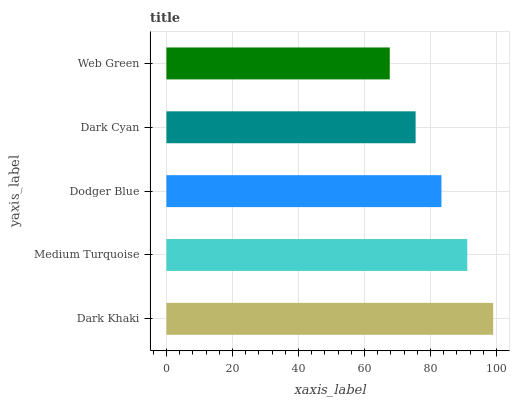Is Web Green the minimum?
Answer yes or no. Yes. Is Dark Khaki the maximum?
Answer yes or no. Yes. Is Medium Turquoise the minimum?
Answer yes or no. No. Is Medium Turquoise the maximum?
Answer yes or no. No. Is Dark Khaki greater than Medium Turquoise?
Answer yes or no. Yes. Is Medium Turquoise less than Dark Khaki?
Answer yes or no. Yes. Is Medium Turquoise greater than Dark Khaki?
Answer yes or no. No. Is Dark Khaki less than Medium Turquoise?
Answer yes or no. No. Is Dodger Blue the high median?
Answer yes or no. Yes. Is Dodger Blue the low median?
Answer yes or no. Yes. Is Medium Turquoise the high median?
Answer yes or no. No. Is Dark Cyan the low median?
Answer yes or no. No. 